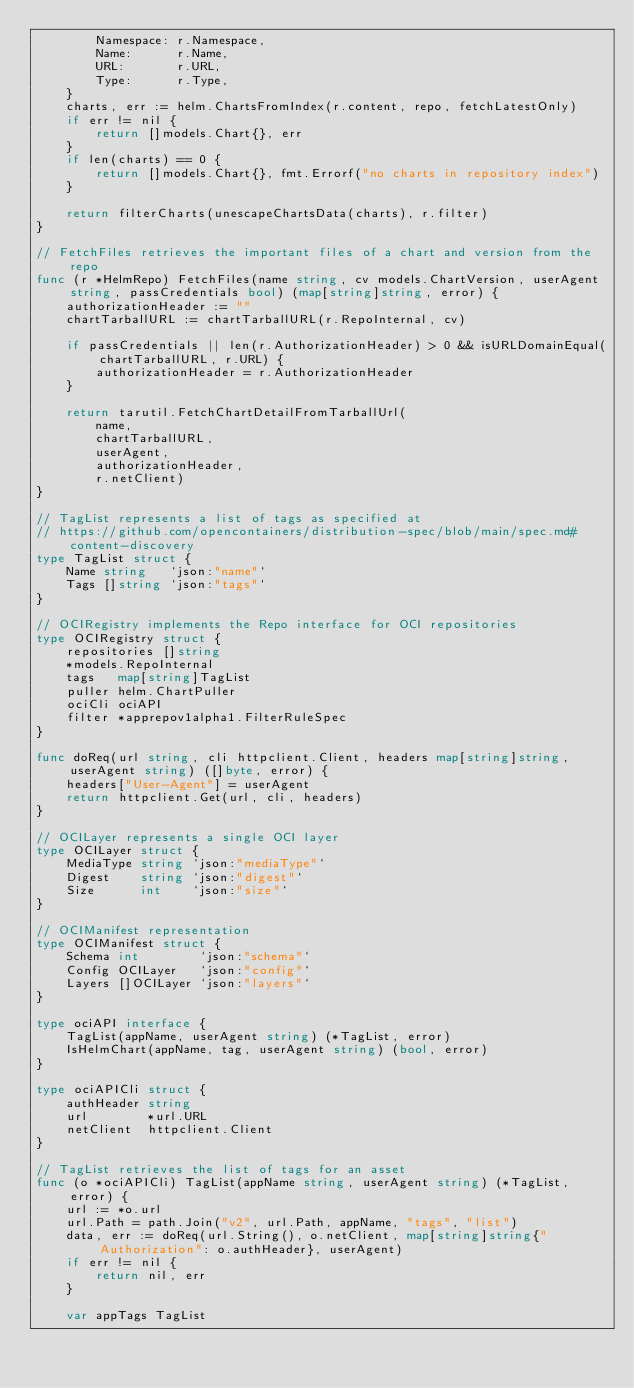Convert code to text. <code><loc_0><loc_0><loc_500><loc_500><_Go_>		Namespace: r.Namespace,
		Name:      r.Name,
		URL:       r.URL,
		Type:      r.Type,
	}
	charts, err := helm.ChartsFromIndex(r.content, repo, fetchLatestOnly)
	if err != nil {
		return []models.Chart{}, err
	}
	if len(charts) == 0 {
		return []models.Chart{}, fmt.Errorf("no charts in repository index")
	}

	return filterCharts(unescapeChartsData(charts), r.filter)
}

// FetchFiles retrieves the important files of a chart and version from the repo
func (r *HelmRepo) FetchFiles(name string, cv models.ChartVersion, userAgent string, passCredentials bool) (map[string]string, error) {
	authorizationHeader := ""
	chartTarballURL := chartTarballURL(r.RepoInternal, cv)

	if passCredentials || len(r.AuthorizationHeader) > 0 && isURLDomainEqual(chartTarballURL, r.URL) {
		authorizationHeader = r.AuthorizationHeader
	}

	return tarutil.FetchChartDetailFromTarballUrl(
		name,
		chartTarballURL,
		userAgent,
		authorizationHeader,
		r.netClient)
}

// TagList represents a list of tags as specified at
// https://github.com/opencontainers/distribution-spec/blob/main/spec.md#content-discovery
type TagList struct {
	Name string   `json:"name"`
	Tags []string `json:"tags"`
}

// OCIRegistry implements the Repo interface for OCI repositories
type OCIRegistry struct {
	repositories []string
	*models.RepoInternal
	tags   map[string]TagList
	puller helm.ChartPuller
	ociCli ociAPI
	filter *apprepov1alpha1.FilterRuleSpec
}

func doReq(url string, cli httpclient.Client, headers map[string]string, userAgent string) ([]byte, error) {
	headers["User-Agent"] = userAgent
	return httpclient.Get(url, cli, headers)
}

// OCILayer represents a single OCI layer
type OCILayer struct {
	MediaType string `json:"mediaType"`
	Digest    string `json:"digest"`
	Size      int    `json:"size"`
}

// OCIManifest representation
type OCIManifest struct {
	Schema int        `json:"schema"`
	Config OCILayer   `json:"config"`
	Layers []OCILayer `json:"layers"`
}

type ociAPI interface {
	TagList(appName, userAgent string) (*TagList, error)
	IsHelmChart(appName, tag, userAgent string) (bool, error)
}

type ociAPICli struct {
	authHeader string
	url        *url.URL
	netClient  httpclient.Client
}

// TagList retrieves the list of tags for an asset
func (o *ociAPICli) TagList(appName string, userAgent string) (*TagList, error) {
	url := *o.url
	url.Path = path.Join("v2", url.Path, appName, "tags", "list")
	data, err := doReq(url.String(), o.netClient, map[string]string{"Authorization": o.authHeader}, userAgent)
	if err != nil {
		return nil, err
	}

	var appTags TagList</code> 